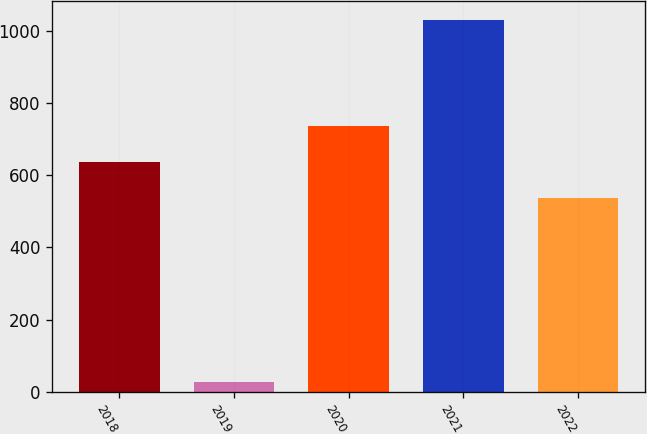Convert chart. <chart><loc_0><loc_0><loc_500><loc_500><bar_chart><fcel>2018<fcel>2019<fcel>2020<fcel>2021<fcel>2022<nl><fcel>637.4<fcel>27<fcel>737.8<fcel>1031<fcel>537<nl></chart> 